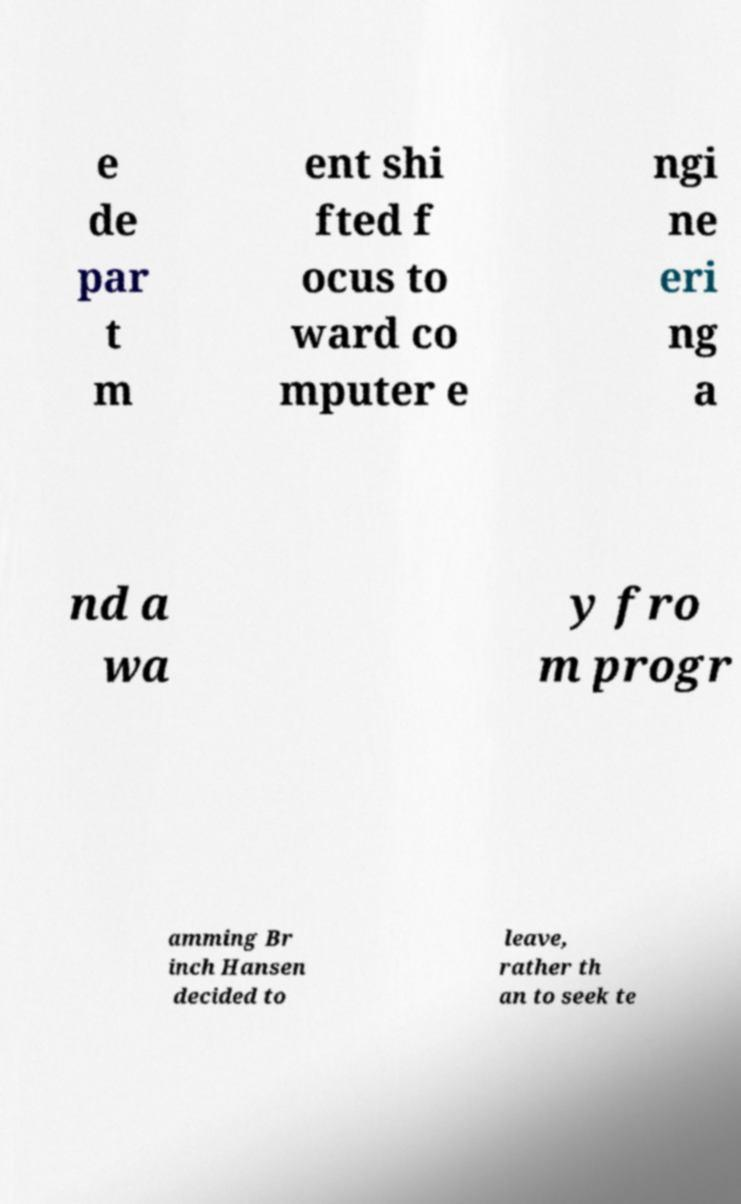Can you accurately transcribe the text from the provided image for me? e de par t m ent shi fted f ocus to ward co mputer e ngi ne eri ng a nd a wa y fro m progr amming Br inch Hansen decided to leave, rather th an to seek te 